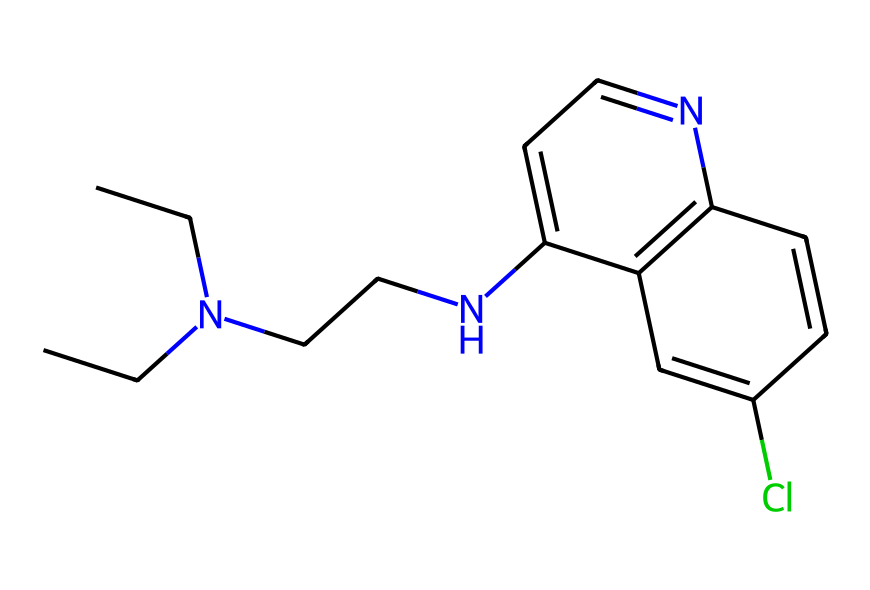How many carbon atoms are in this chemical? To determine the number of carbon atoms, we can analyze the SMILES representation and count each carbon (C) symbol. In this case, there are a total of 12 carbon atoms present in the structure.
Answer: 12 What is the primary functional group present in this compound? By examining the SMILES and recognizing the structure of the compound, we can identify that it possesses a secondary amine (represented by the -N- bonded to two carbon chains) and also contains a chloro (Cl) substituent on an aromatic ring. Thus, the primary functional group is the amino group.
Answer: amino Is this compound an aromatic compound? The presence of a benzene-like structure in the SMILES notation, characterized by alternating double bonds in a ring, indicates that this compound contains aromatic rings. Hence, it is considered an aromatic compound.
Answer: yes How many nitrogen atoms are present in this chemical? By looking at the SMILES representation, we can identify the nitrogen (N) atoms. In this chemical, there are two nitrogen atoms reflected in the structure, both contributing to the properties of the drug.
Answer: 2 What type of drug is chloroquine classified as? Chloroquine is primarily classified based on its application and chemical structure within pharmaceuticals. It is recognized as an antimalarial drug, specifically used in the treatment of malaria infections.
Answer: antimalarial What is the significance of chloroquine in historical terms? Chloroquine has significant historical importance as it was widely used throughout the 20th century for treating malaria and reducing mortality rates in endemic regions. Its discovery marked a turning point in malaria treatment.
Answer: historical significance in malaria treatment 